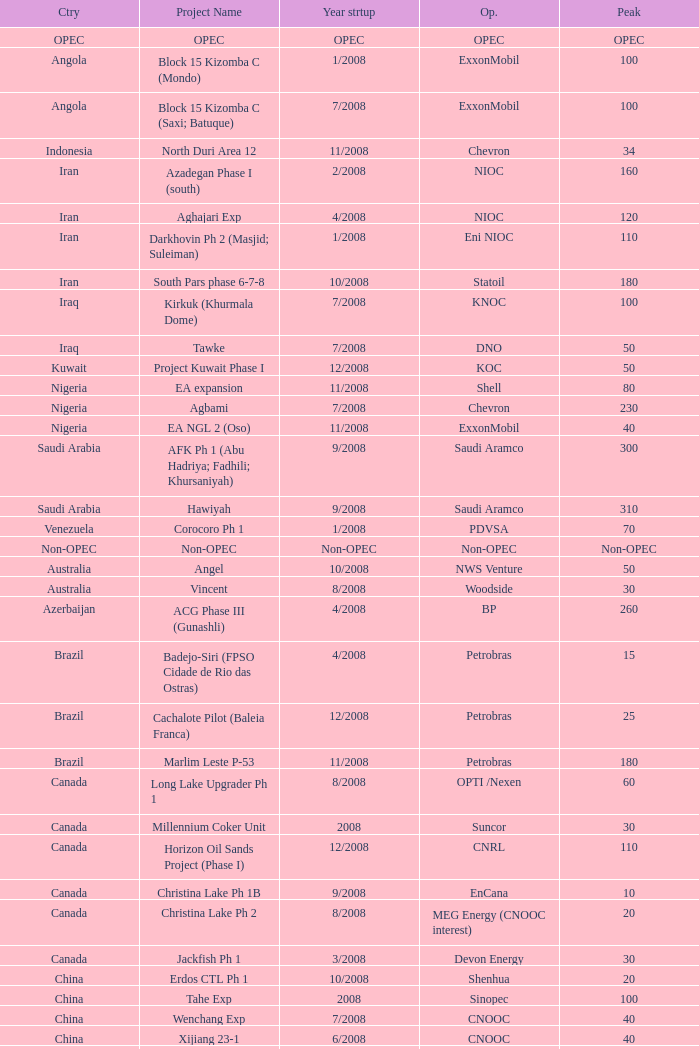What is the Operator with a Peak that is 55? PEMEX. 